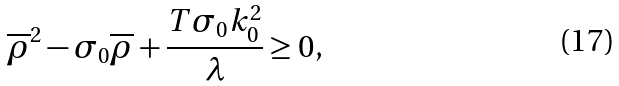<formula> <loc_0><loc_0><loc_500><loc_500>\overline { \rho } ^ { 2 } - \sigma _ { 0 } \overline { \rho } + \frac { T \sigma _ { 0 } k _ { 0 } ^ { 2 } } { \lambda } \geq 0 ,</formula> 